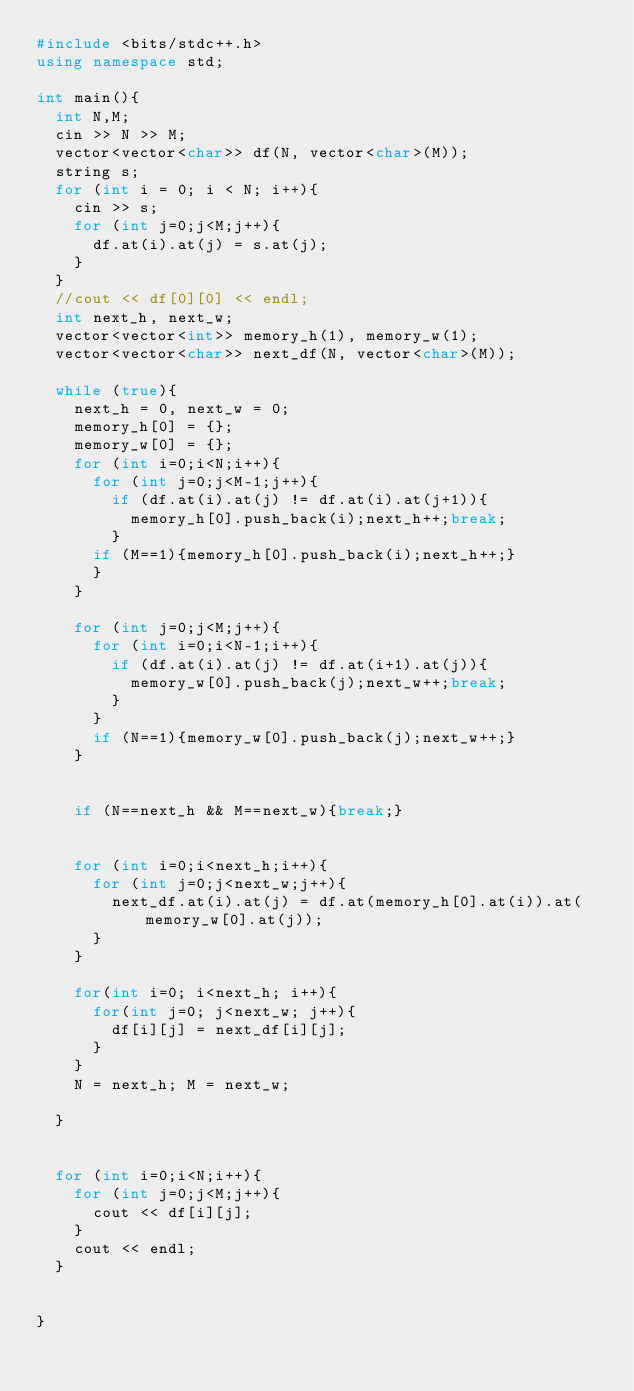<code> <loc_0><loc_0><loc_500><loc_500><_C++_>#include <bits/stdc++.h>
using namespace std;

int main(){
  int N,M;
  cin >> N >> M;
  vector<vector<char>> df(N, vector<char>(M));
  string s;
  for (int i = 0; i < N; i++){
    cin >> s;
    for (int j=0;j<M;j++){
      df.at(i).at(j) = s.at(j);
    }
  }
  //cout << df[0][0] << endl;
  int next_h, next_w;
  vector<vector<int>> memory_h(1), memory_w(1);
  vector<vector<char>> next_df(N, vector<char>(M));
  
  while (true){
    next_h = 0, next_w = 0;
    memory_h[0] = {};
    memory_w[0] = {};
    for (int i=0;i<N;i++){
      for (int j=0;j<M-1;j++){
        if (df.at(i).at(j) != df.at(i).at(j+1)){
          memory_h[0].push_back(i);next_h++;break;
        }
      if (M==1){memory_h[0].push_back(i);next_h++;}
      }
    }
    
    for (int j=0;j<M;j++){
      for (int i=0;i<N-1;i++){
        if (df.at(i).at(j) != df.at(i+1).at(j)){
          memory_w[0].push_back(j);next_w++;break;
        }
      }
      if (N==1){memory_w[0].push_back(j);next_w++;}
    }
    
    
    if (N==next_h && M==next_w){break;}

    
    for (int i=0;i<next_h;i++){
      for (int j=0;j<next_w;j++){
        next_df.at(i).at(j) = df.at(memory_h[0].at(i)).at(memory_w[0].at(j));
      }
    }

    for(int i=0; i<next_h; i++){
      for(int j=0; j<next_w; j++){
        df[i][j] = next_df[i][j];
      }
    }
    N = next_h; M = next_w;

  }
  
  
  for (int i=0;i<N;i++){
    for (int j=0;j<M;j++){
      cout << df[i][j];
    }
    cout << endl;
  }
  
  
}</code> 